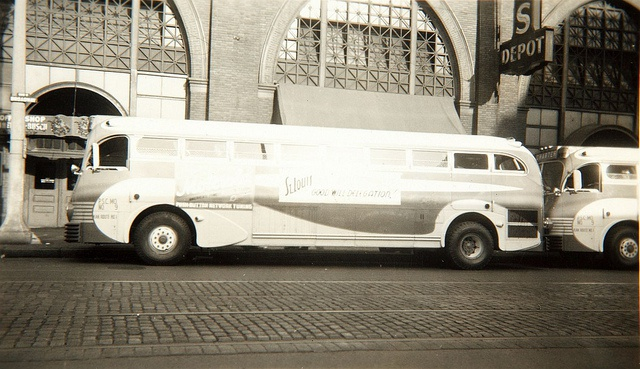Describe the objects in this image and their specific colors. I can see bus in black, ivory, darkgray, and gray tones and bus in black, ivory, tan, and darkgray tones in this image. 